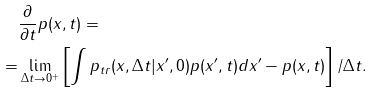Convert formula to latex. <formula><loc_0><loc_0><loc_500><loc_500>& \frac { \partial } { \partial t } p ( { x } , t ) = \\ = & \lim _ { \Delta t \to 0 ^ { + } } \left [ \int p _ { t r } ( { x } , \Delta t | { x } ^ { \prime } , 0 ) p ( { x } ^ { \prime } , t ) d { x } ^ { \prime } - p ( { x } , t ) \right ] / \Delta t .</formula> 